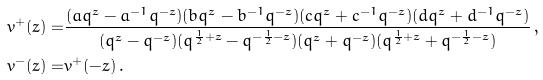Convert formula to latex. <formula><loc_0><loc_0><loc_500><loc_500>v ^ { + } ( z ) = & \frac { ( a q ^ { z } - a ^ { - 1 } q ^ { - z } ) ( b q ^ { z } - b ^ { - 1 } q ^ { - z } ) ( c q ^ { z } + c ^ { - 1 } q ^ { - z } ) ( d q ^ { z } + d ^ { - 1 } q ^ { - z } ) } { ( q ^ { z } - q ^ { - z } ) ( q ^ { \frac { 1 } { 2 } + z } - q ^ { - \frac { 1 } { 2 } - z } ) ( q ^ { z } + q ^ { - z } ) ( q ^ { \frac { 1 } { 2 } + z } + q ^ { - \frac { 1 } { 2 } - z } ) } \, , \\ v ^ { - } ( z ) = & v ^ { + } ( - z ) \, .</formula> 